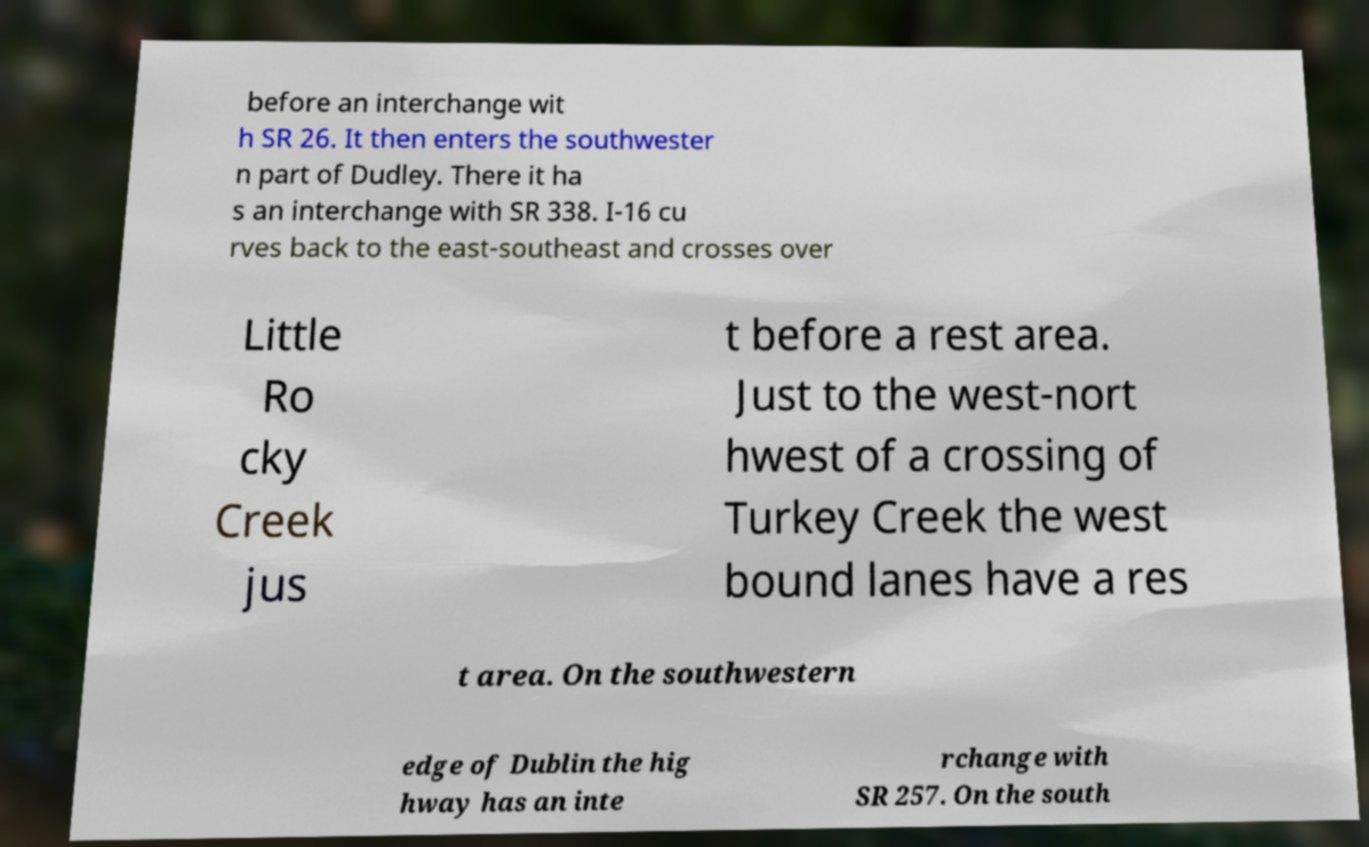Please identify and transcribe the text found in this image. before an interchange wit h SR 26. It then enters the southwester n part of Dudley. There it ha s an interchange with SR 338. I-16 cu rves back to the east-southeast and crosses over Little Ro cky Creek jus t before a rest area. Just to the west-nort hwest of a crossing of Turkey Creek the west bound lanes have a res t area. On the southwestern edge of Dublin the hig hway has an inte rchange with SR 257. On the south 